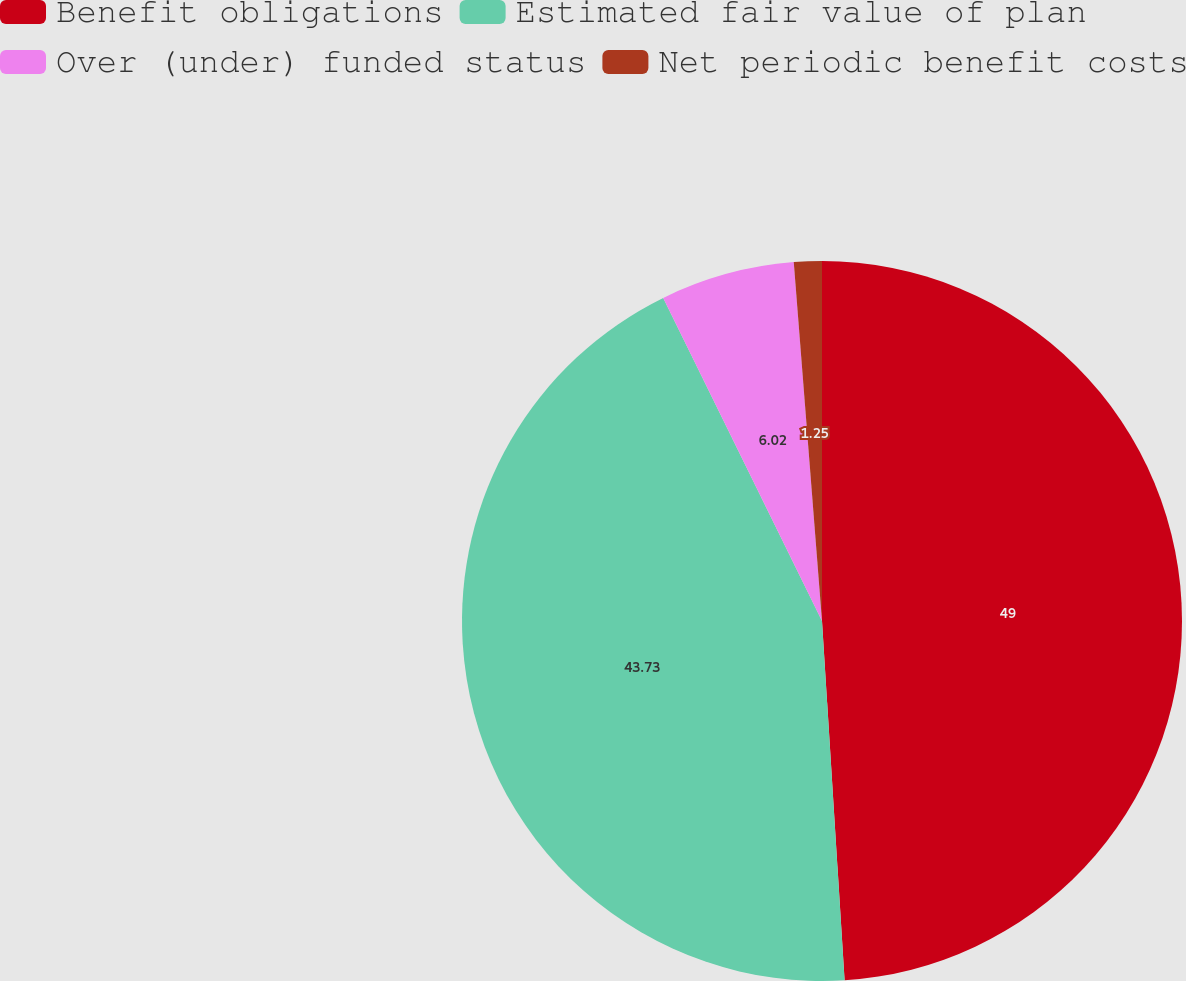Convert chart. <chart><loc_0><loc_0><loc_500><loc_500><pie_chart><fcel>Benefit obligations<fcel>Estimated fair value of plan<fcel>Over (under) funded status<fcel>Net periodic benefit costs<nl><fcel>49.0%<fcel>43.73%<fcel>6.02%<fcel>1.25%<nl></chart> 